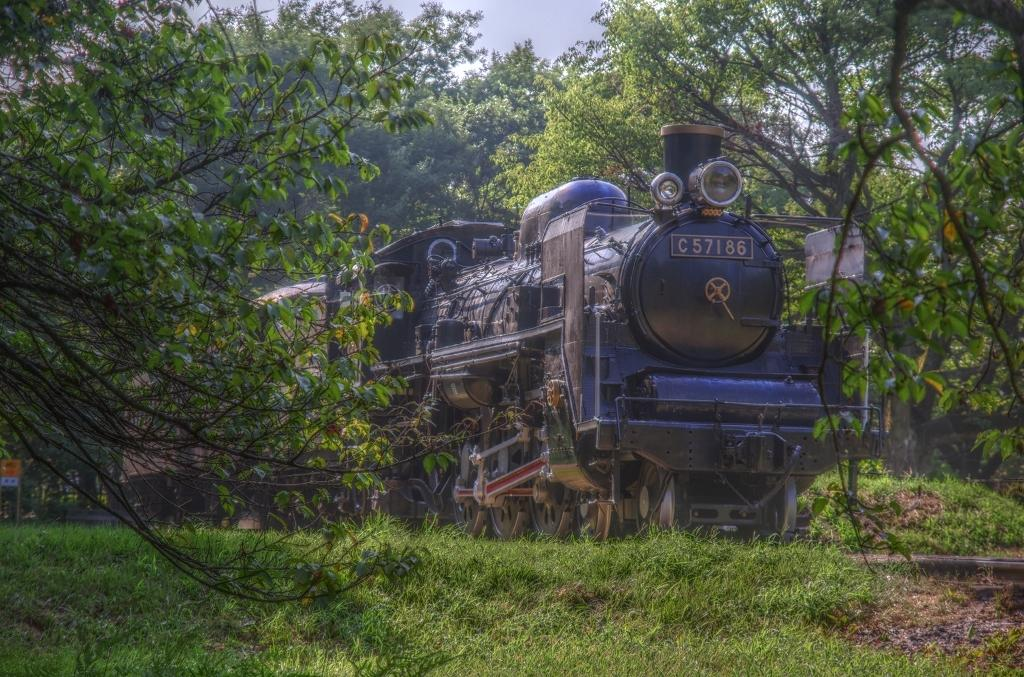What is the main subject in the center of the image? There is a train in the center of the image. What can be seen in the background of the image? There are trees in the background of the image. What is visible at the top of the image? The sky is visible at the top of the image. What is visible at the bottom of the image? The ground is visible at the bottom of the image. What object is present in the image besides the train, trees, sky, and ground? There is a board present in the image. What type of texture can be seen on the pump in the image? There is no pump present in the image; it features a train, trees, sky, ground, and a board. 